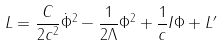<formula> <loc_0><loc_0><loc_500><loc_500>L = \frac { C } { 2 c ^ { 2 } } \dot { \Phi } ^ { 2 } - \frac { 1 } { 2 \Lambda } \Phi ^ { 2 } + \frac { 1 } { c } I \Phi + L ^ { \prime }</formula> 